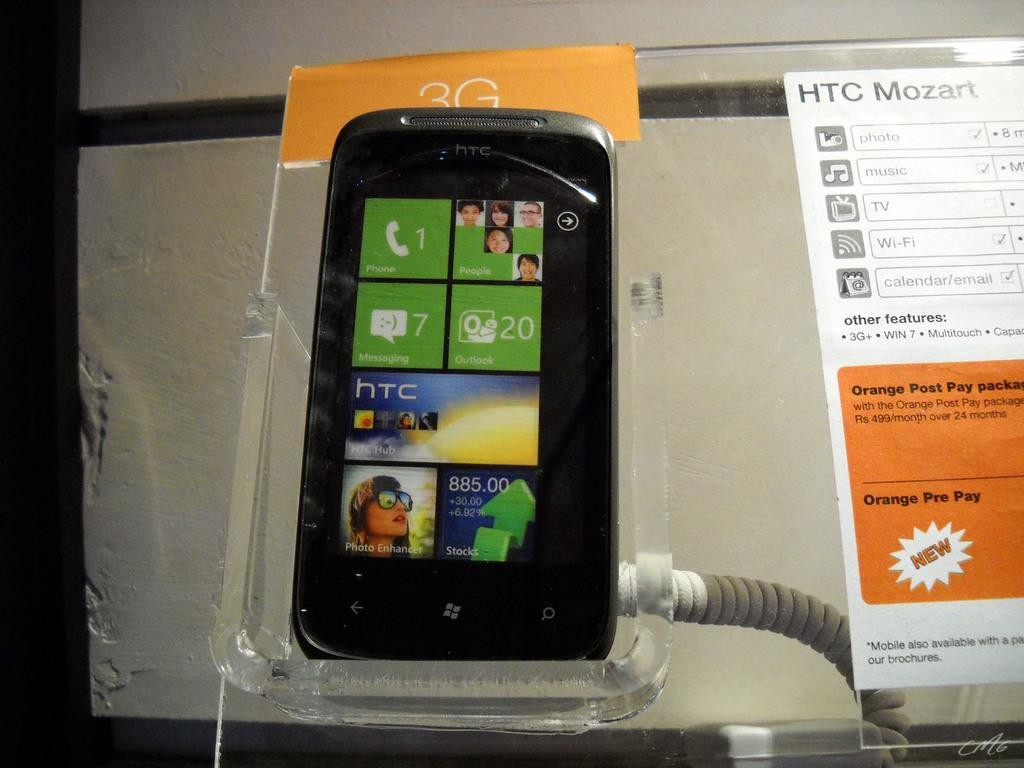Provide a one-sentence caption for the provided image. the front of an htc mozart, still in its packaging. 